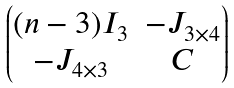Convert formula to latex. <formula><loc_0><loc_0><loc_500><loc_500>\begin{pmatrix} ( n - 3 ) I _ { 3 } & - J _ { 3 \times 4 } \\ - J _ { 4 \times 3 } & C \end{pmatrix}</formula> 